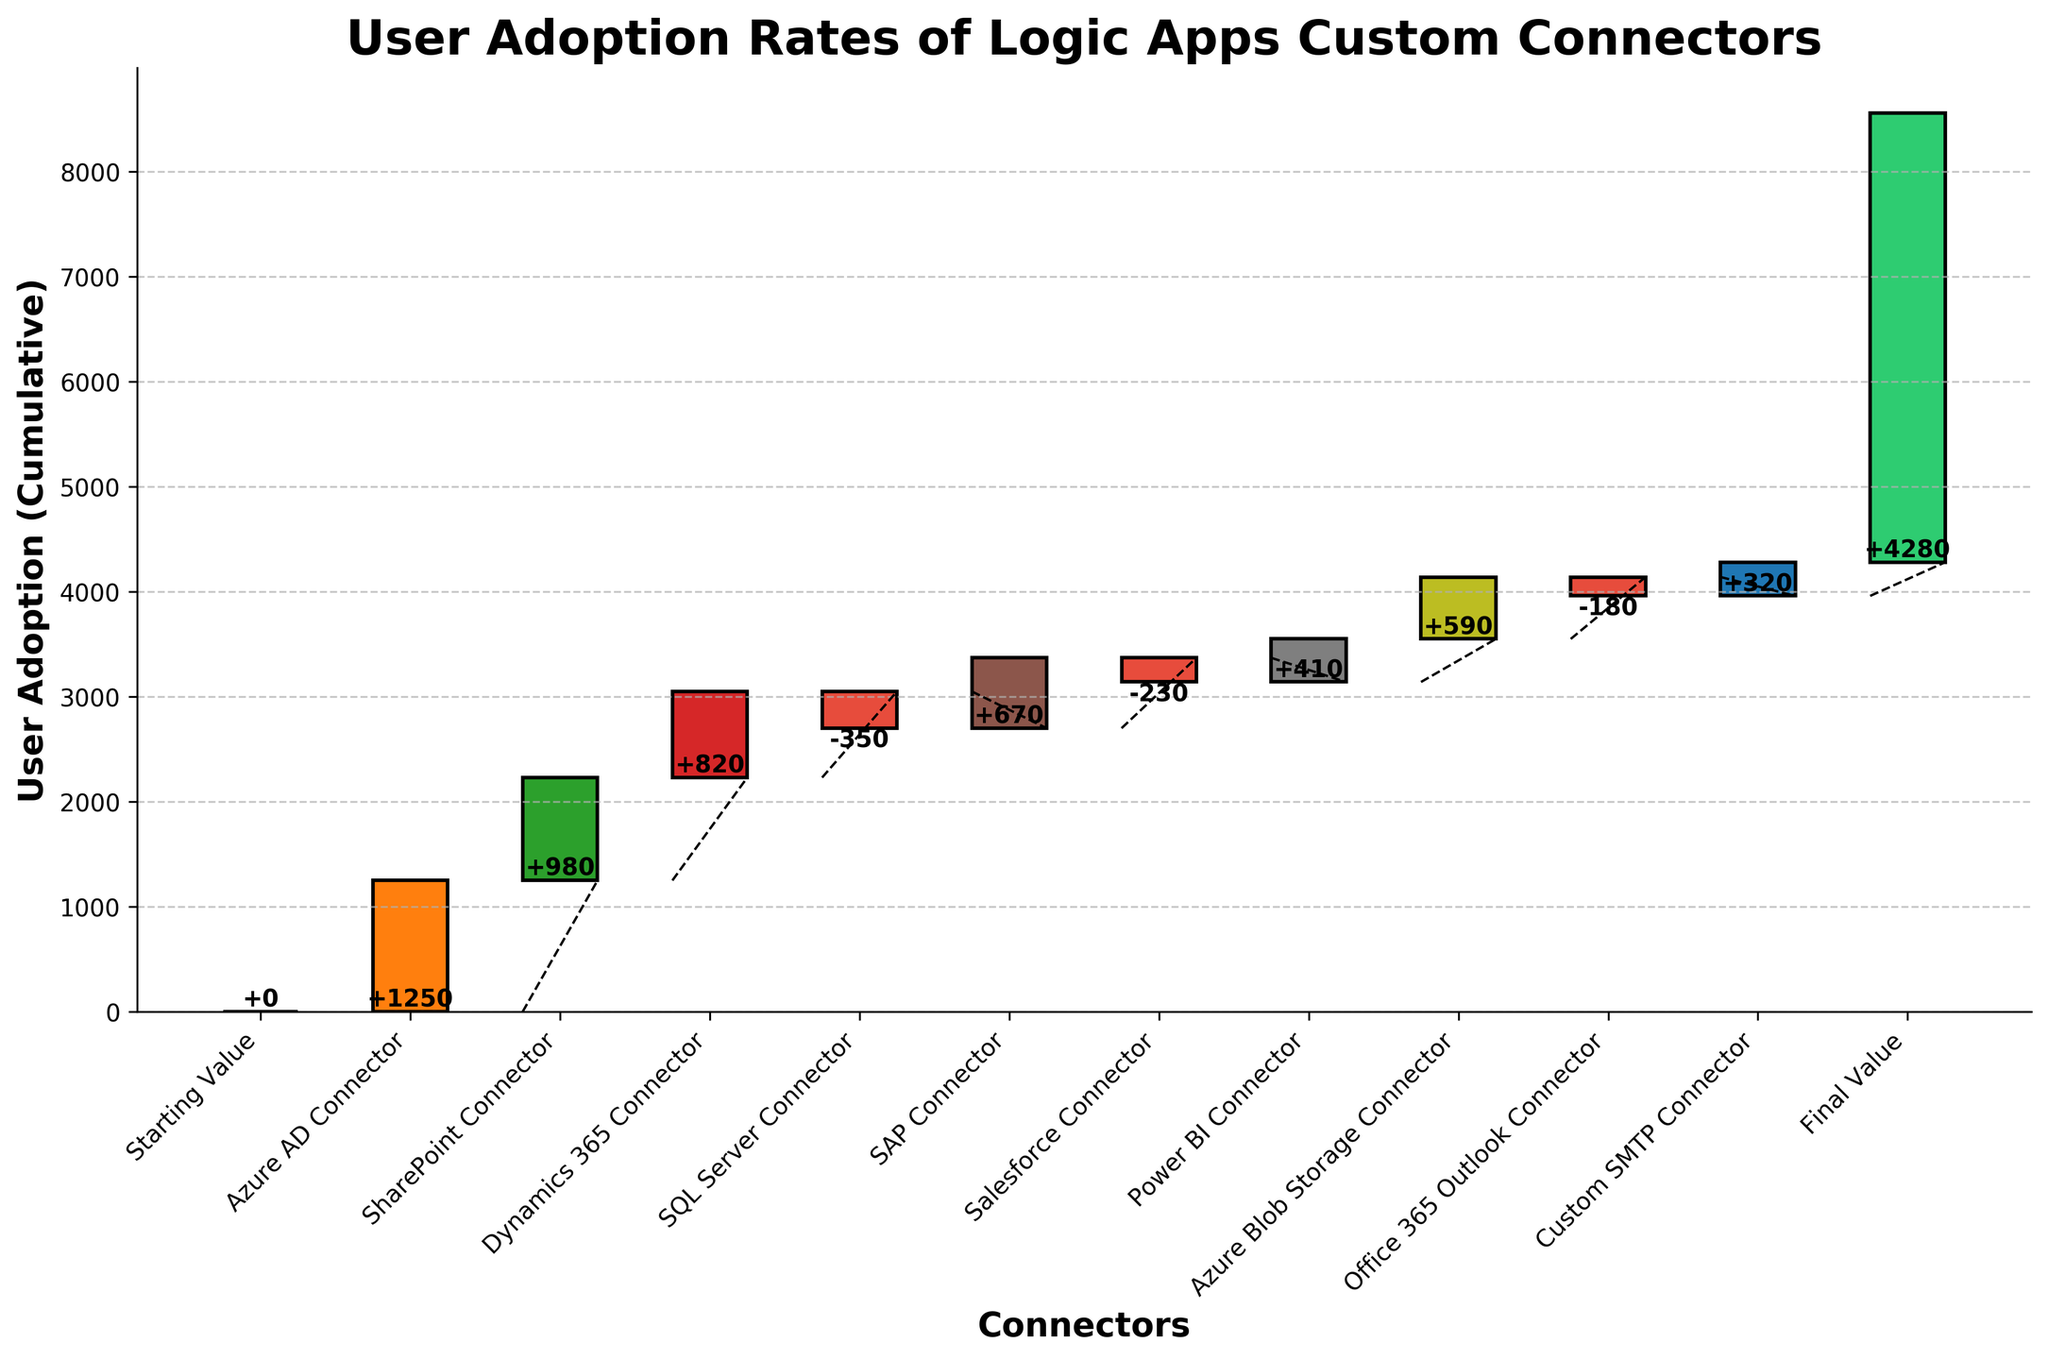What's the title of the chart? The title of the chart is displayed at the top center and reads "User Adoption Rates of Logic Apps Custom Connectors".
Answer: User Adoption Rates of Logic Apps Custom Connectors How many connectors have a negative adoption rate? The negative adoption rates are represented by the downward extending red bars in the figure. There are three red bars corresponding to the SQL Server Connector, Salesforce Connector, and Office 365 Outlook Connector.
Answer: 3 What is the cumulative user adoption rate of the Azure Blob Storage Connector? The Azure Blob Storage Connector adds a value of 590 to the previous cumulative total. The cumulative total at this step is its starting value plus additions and subtractions of all previous connectors including itself. From this connector, the cumulative additions are 1250 + 980 + 820 - 350 + 670 - 230 + 410 + 590.
Answer: 4140 Which connector had the highest positive adoption rate? By looking at the bar heights above the zero line, the Azure AD Connector, with the tallest bar among the positive adopters, has the highest positive rate.
Answer: Azure AD Connector If we exclude the connectors with negative adoption rates, what's the new final value for user adoption? Excluding the connectors SQL Server, Salesforce, and Office 365 Outlook, the adjusted final value is the sum of all positive values starting from a base of zero. That is, 1250 + 980 + 820 + 670 + 410 + 590 + 320.
Answer: 5040 Which connector directly follows the Power BI Connector in the order, and what is its adoption rate? From the x-axis labels, the connector following the Power BI Connector is the Azure Blob Storage Connector, which shows a user adoption rate of 590.
Answer: Azure Blob Storage Connector, 590 Is the cumulative adoption at the end higher or lower compared to the cumulative adoption after the Dynamics 365 Connector? The cumulative adoption after the Dynamics 365 Connector is the sum of Starting Value, Azure AD, SharePoint, and Dynamics 365 (0 + 1250 + 980 + 820 = 3050). The final cumulative at the end is 4280. Comparing these values, 4280 is higher than 3050.
Answer: Higher What is the percentage contribution of the SharePoint Connector to the final value? The percentage contribution is calculated by (value of SharePoint Connector / final value) * 100 = (980 / 4280) * 100.
Answer: ~22.9% What trend do we observe with the adoption rates concerning positive versus negative connectors? By analyzing the chart, positive adoptions show a rising trend indicated by upward bars, whereas negative adoptions intermittently show dips but are fewer, reflecting overall growing user adoption, with aggregate positive trends despite some connectors having negative rates.
Answer: Overall positive trend 